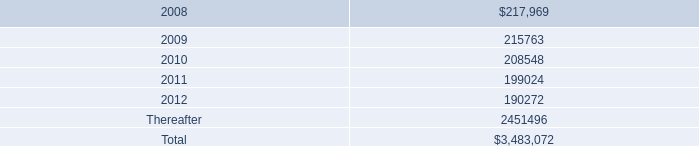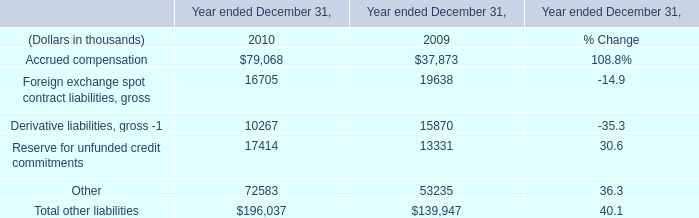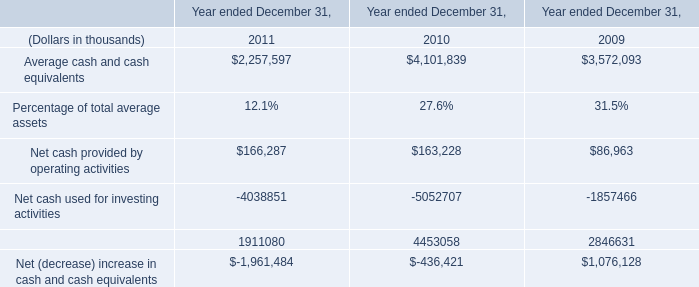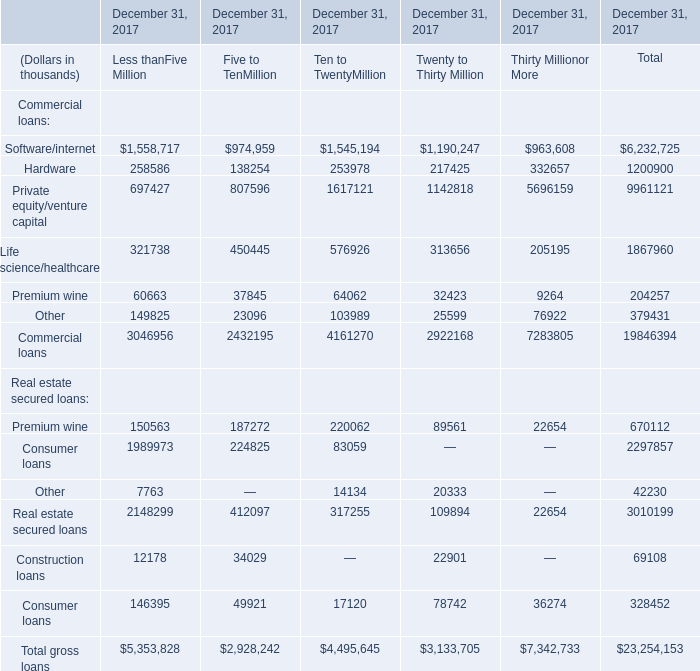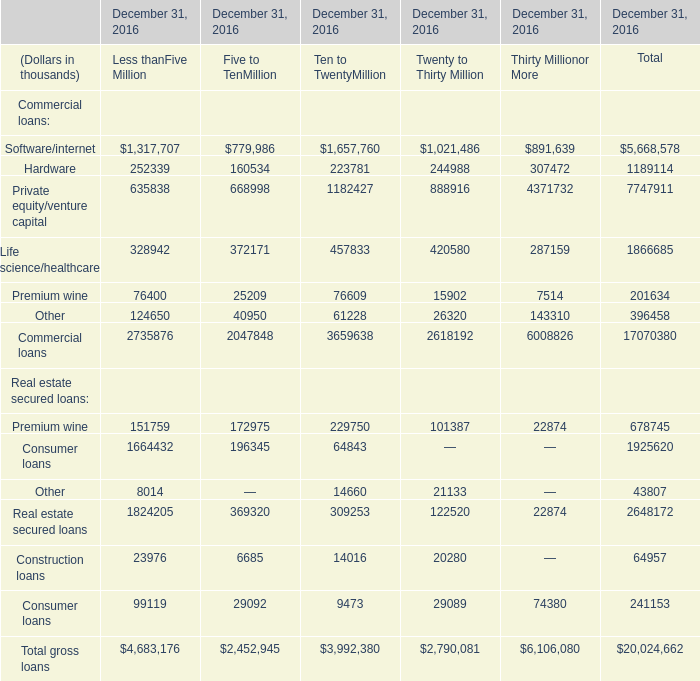what's the total amount of Life science/healthcare of December 31, 2016 Ten to TwentyMillion, and Hardware of December 31, 2017 Twenty to Thirty Million ? 
Computations: (457833.0 + 217425.0)
Answer: 675258.0. 